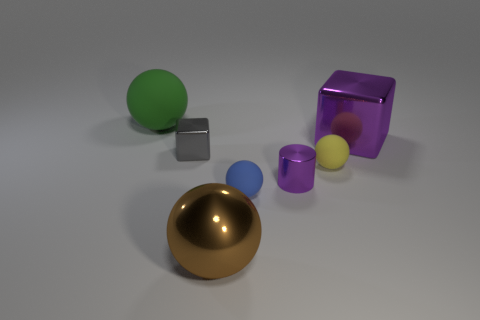There is a big metallic thing that is the same color as the cylinder; what shape is it?
Your answer should be very brief. Cube. How many other things are the same shape as the tiny blue object?
Your answer should be very brief. 3. What number of shiny objects are brown things or big spheres?
Your response must be concise. 1. The big ball in front of the purple thing that is right of the small purple cylinder is made of what material?
Your response must be concise. Metal. Are there more small cylinders to the left of the large green object than large gray metallic cylinders?
Offer a very short reply. No. Is there another gray thing that has the same material as the tiny gray object?
Keep it short and to the point. No. Is the shape of the small shiny object right of the small gray metal thing the same as  the large brown thing?
Keep it short and to the point. No. How many big brown spheres are on the right side of the big ball that is in front of the big shiny thing that is on the right side of the brown thing?
Provide a succinct answer. 0. Are there fewer purple cylinders behind the tiny shiny cube than cubes in front of the small purple metal object?
Provide a short and direct response. No. What is the color of the other big matte thing that is the same shape as the blue thing?
Your answer should be compact. Green. 